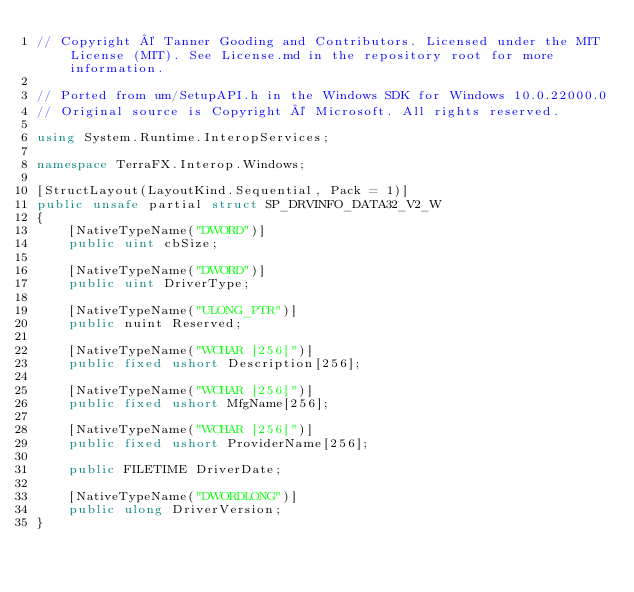Convert code to text. <code><loc_0><loc_0><loc_500><loc_500><_C#_>// Copyright © Tanner Gooding and Contributors. Licensed under the MIT License (MIT). See License.md in the repository root for more information.

// Ported from um/SetupAPI.h in the Windows SDK for Windows 10.0.22000.0
// Original source is Copyright © Microsoft. All rights reserved.

using System.Runtime.InteropServices;

namespace TerraFX.Interop.Windows;

[StructLayout(LayoutKind.Sequential, Pack = 1)]
public unsafe partial struct SP_DRVINFO_DATA32_V2_W
{
    [NativeTypeName("DWORD")]
    public uint cbSize;

    [NativeTypeName("DWORD")]
    public uint DriverType;

    [NativeTypeName("ULONG_PTR")]
    public nuint Reserved;

    [NativeTypeName("WCHAR [256]")]
    public fixed ushort Description[256];

    [NativeTypeName("WCHAR [256]")]
    public fixed ushort MfgName[256];

    [NativeTypeName("WCHAR [256]")]
    public fixed ushort ProviderName[256];

    public FILETIME DriverDate;

    [NativeTypeName("DWORDLONG")]
    public ulong DriverVersion;
}
</code> 